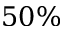Convert formula to latex. <formula><loc_0><loc_0><loc_500><loc_500>5 0 \%</formula> 